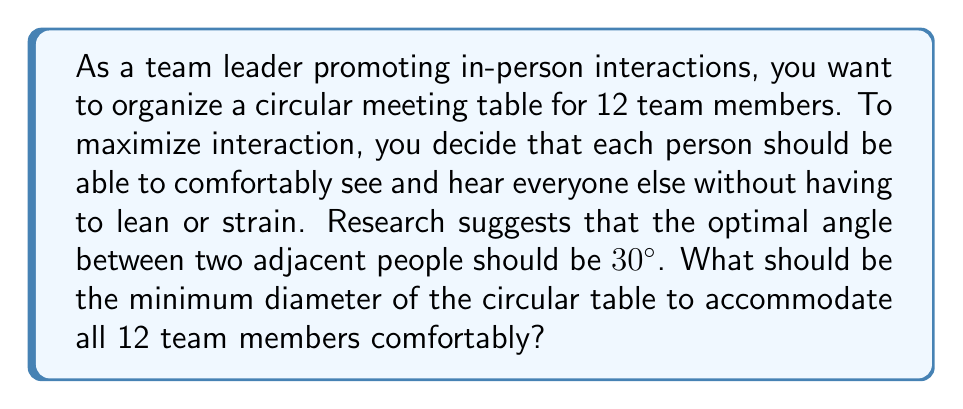Help me with this question. Let's approach this step-by-step:

1) In a circle, there are 360°. With 12 people, each person should occupy:
   
   $\frac{360°}{12} = 30°$

   This aligns with the optimal angle for interaction.

2) We can divide the circle into 12 equal triangles, each with a central angle of 30°.

3) In each of these triangles:
   - The central angle is 30°
   - We need to find the radius of the circle, which will be the height of the triangle
   - Half of the space a person occupies can be considered as the base of the triangle

4) Let's assume each person needs about 60 cm of space along the circumference. So, half of this (30 cm) will be the base of our triangle.

5) We can use the tangent function to find the radius:

   $\tan(15°) = \frac{\text{opposite}}{\text{adjacent}} = \frac{30 \text{ cm}}{\text{radius}}$

6) Solving for radius:

   $\text{radius} = \frac{30 \text{ cm}}{\tan(15°)} \approx 111.96 \text{ cm}$

7) The diameter is twice the radius:

   $\text{diameter} = 2 * 111.96 \text{ cm} \approx 223.92 \text{ cm}$

8) Rounding up to the nearest centimeter for practicality:

   $\text{diameter} = 224 \text{ cm}$ or $2.24 \text{ m}$

[asy]
import geometry;

size(200);
real r = 100;
real angle = 360/12;

pair center = (0,0);
circle c = circle(center, r);
draw(c);

for(int i = 0; i < 12; ++i) {
  pair p = dir(i*angle) * r;
  dot(p);
  draw(center--p, dashed);
}

label("30°", center, dir(angle/2) * 0.7r);
label("r", (0,0)--(r/2,0), N);
[/asy]
Answer: The minimum diameter of the circular table should be approximately 224 cm or 2.24 m. 